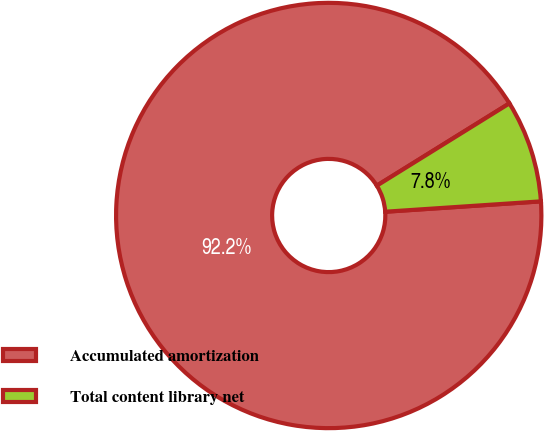<chart> <loc_0><loc_0><loc_500><loc_500><pie_chart><fcel>Accumulated amortization<fcel>Total content library net<nl><fcel>92.22%<fcel>7.78%<nl></chart> 